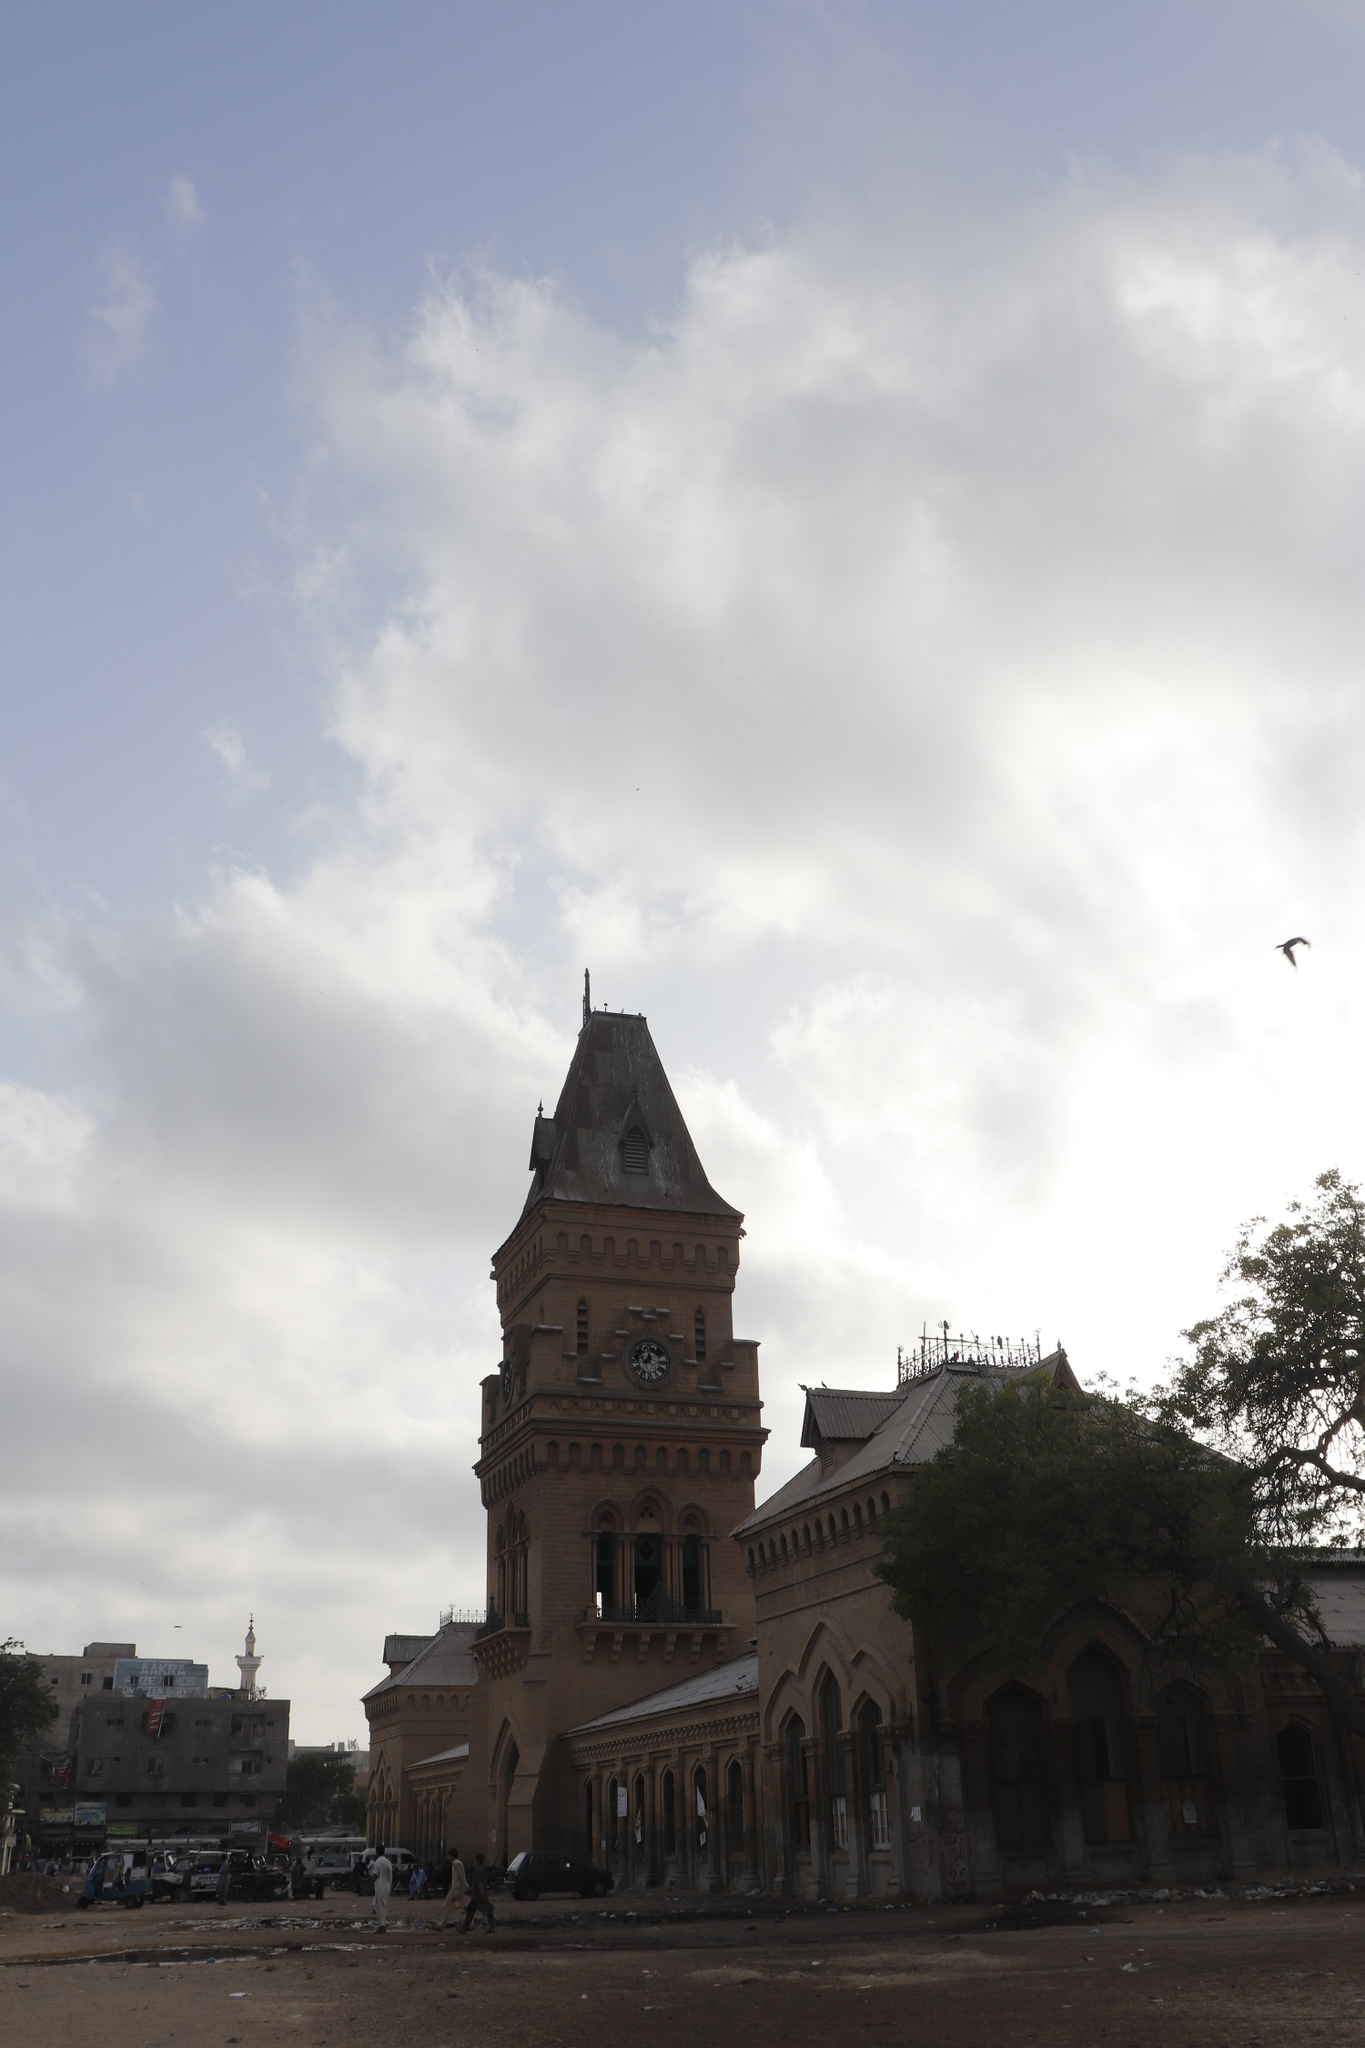Describe the following image. The image prominently features the Empress Market, an iconic historical landmark situated in Karachi, Pakistan. Captured from a low angle, the photograph draws the viewer's attention upwards to the towering clock tower that dominates the scene. The structure, constructed in a light brown hue, is accentuated by its darker roof, highlighting its architectural elegance. Standing out is the clock tower, with its pointed roof and clocks on each facade, reflecting the architectural era of its construction. The building showcases arched windows and a distinctive balcony on the second floor, adding to its historical allure. Overhead, the sky is filled with dramatic clouds creating a compelling backdrop, while birds are seen soaring which adds a dynamic element to the image. On the ground level, the presence of people walking along the street lends a scale to the grandeur of the building and illustrates the constant flow of life around this landmark. This photograph captures a snapshot rich in historical architecture and vibrant, everyday activity. 